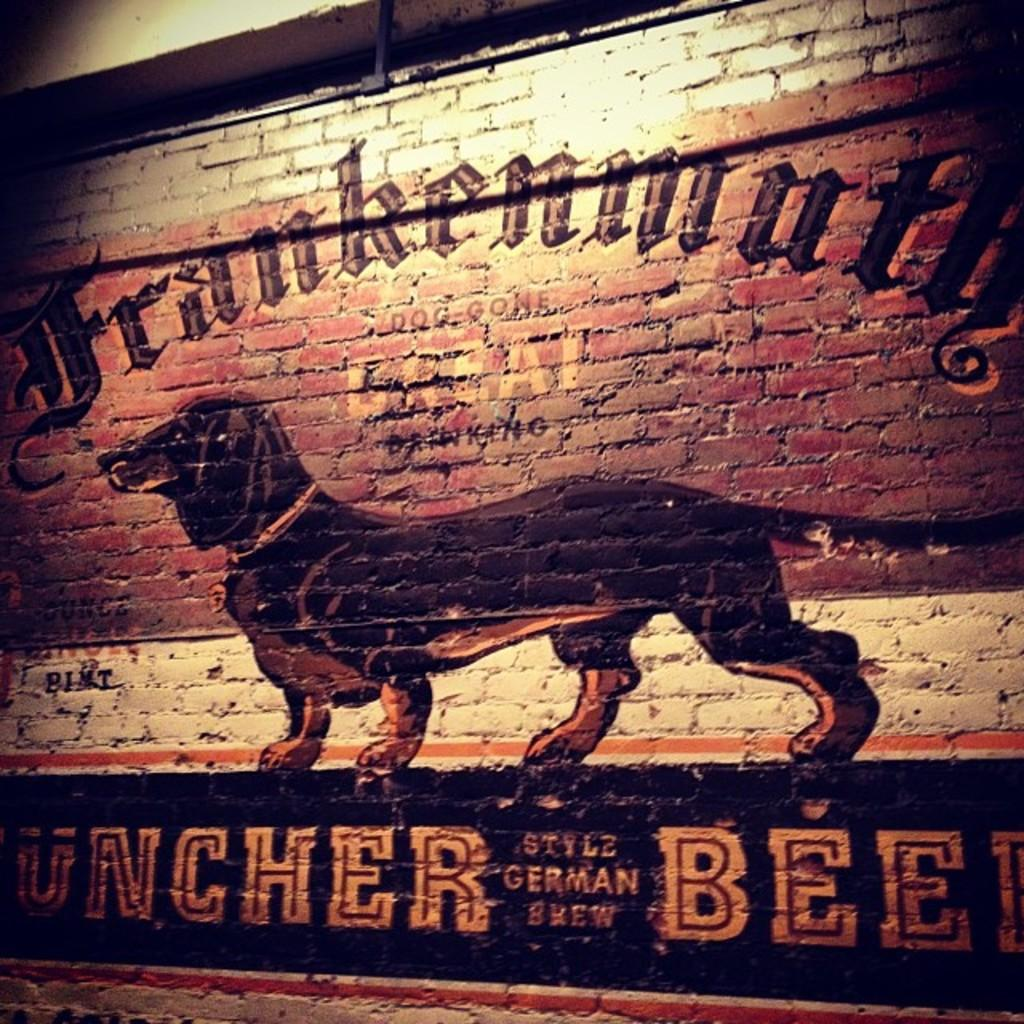What is depicted in the painting on the wall? There is a painting of a dog on the wall. What is the dog in the painting doing? The dog in the painting is standing. What else can be seen on the wall besides the painting? There is writing on the wall. What material is the wall made of? The wall is made of stone bricks. What impulse caused the dog to suddenly look at death in the painting? There is no indication of any impulse or death in the painting; it simply depicts a standing dog. 